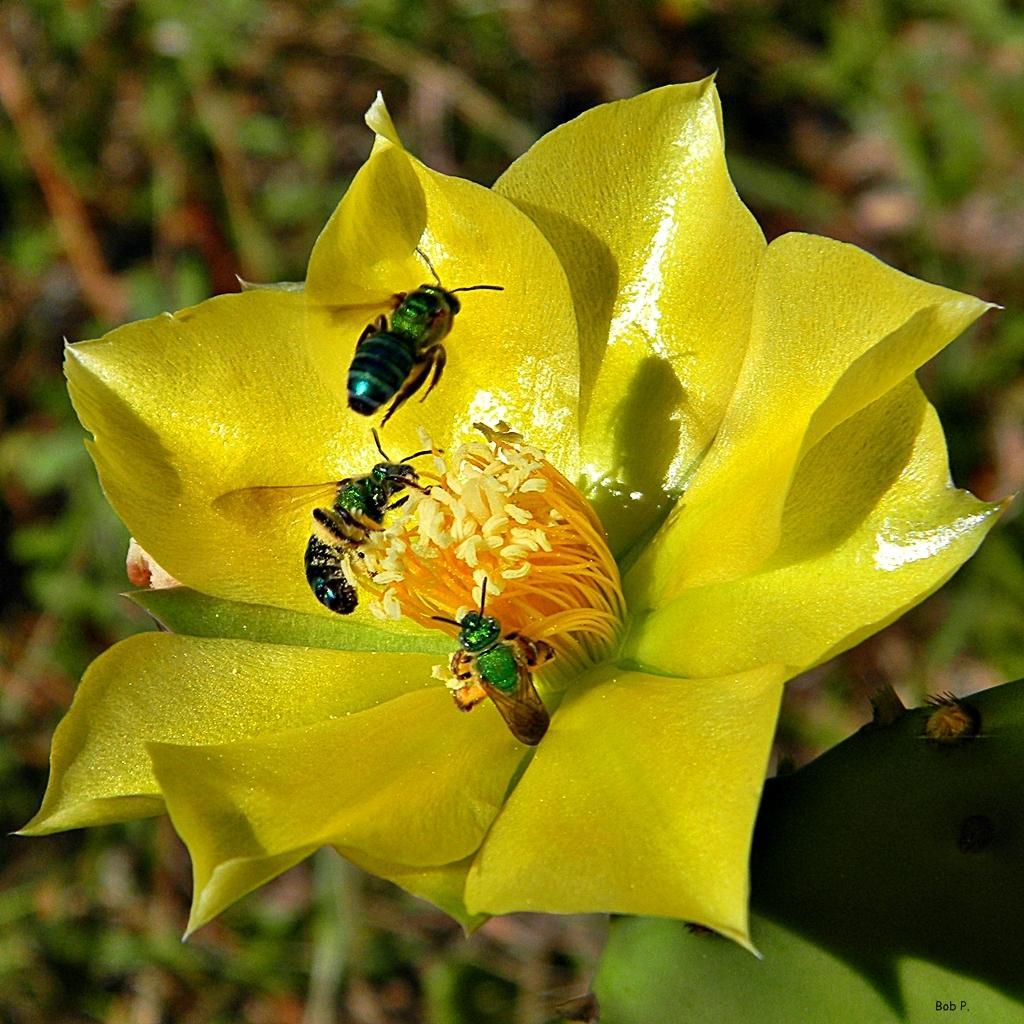In one or two sentences, can you explain what this image depicts? In this image I can see the insects on the flower. In the background, I can see the leaves. 